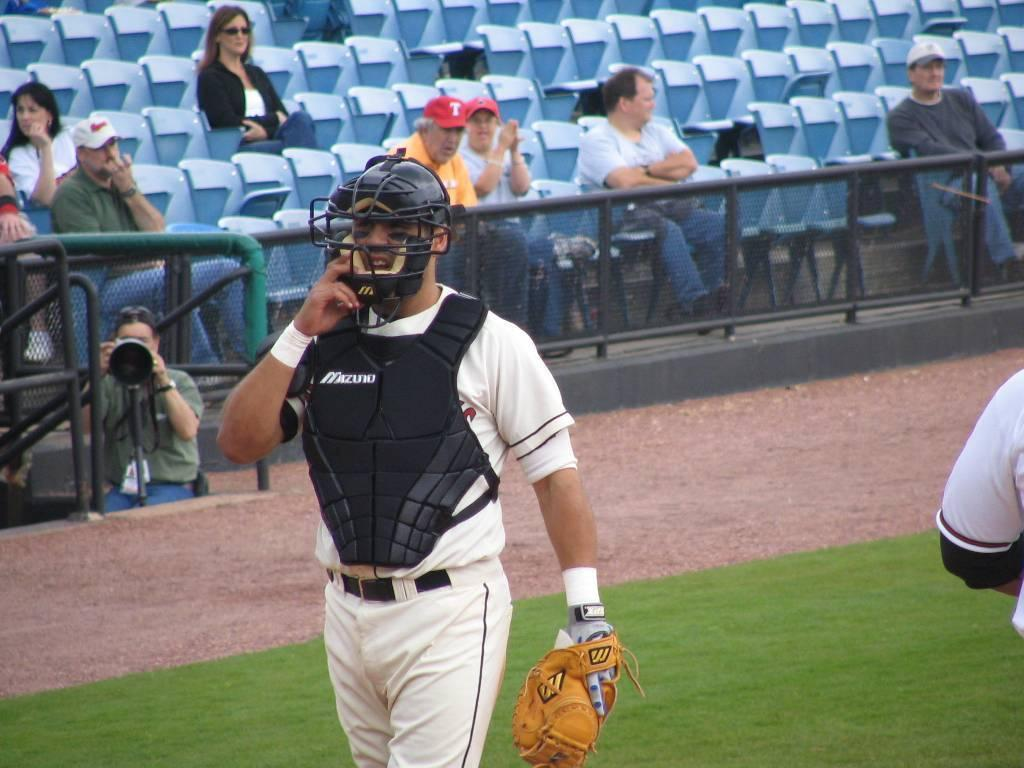<image>
Write a terse but informative summary of the picture. A few people sit in the stand watching a baseball game, one of whom is wearing a red had with the letter T. 